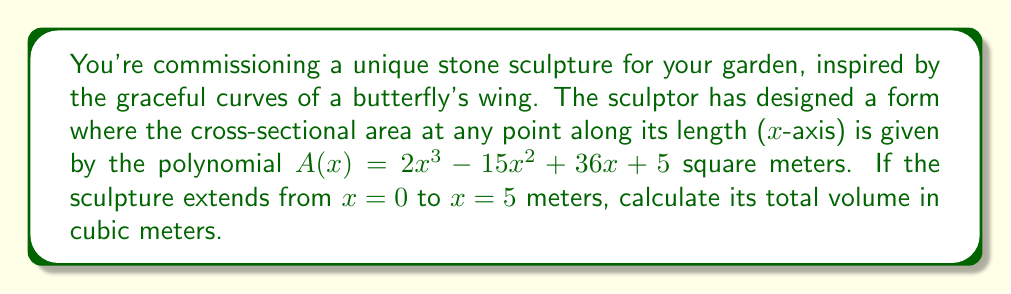Provide a solution to this math problem. To calculate the volume of this complex sculptural form, we need to integrate the cross-sectional area function over the given interval. This is because the volume of a solid with a variable cross-sectional area is given by the integral of the area function.

1) The volume V is given by the definite integral:

   $$V = \int_0^5 A(x) dx$$

2) Substituting the given function:

   $$V = \int_0^5 (2x^3 - 15x^2 + 36x + 5) dx$$

3) Integrate each term:

   $$V = \left[\frac{1}{2}x^4 - 5x^3 + 18x^2 + 5x\right]_0^5$$

4) Evaluate the antiderivative at the upper and lower bounds:

   At x = 5:
   $$\frac{1}{2}(5^4) - 5(5^3) + 18(5^2) + 5(5) = 312.5 - 625 + 450 + 25 = 162.5$$

   At x = 0:
   $$\frac{1}{2}(0^4) - 5(0^3) + 18(0^2) + 5(0) = 0$$

5) Subtract the lower bound value from the upper bound value:

   $$V = 162.5 - 0 = 162.5$$

Therefore, the volume of the sculpture is 162.5 cubic meters.
Answer: 162.5 cubic meters 